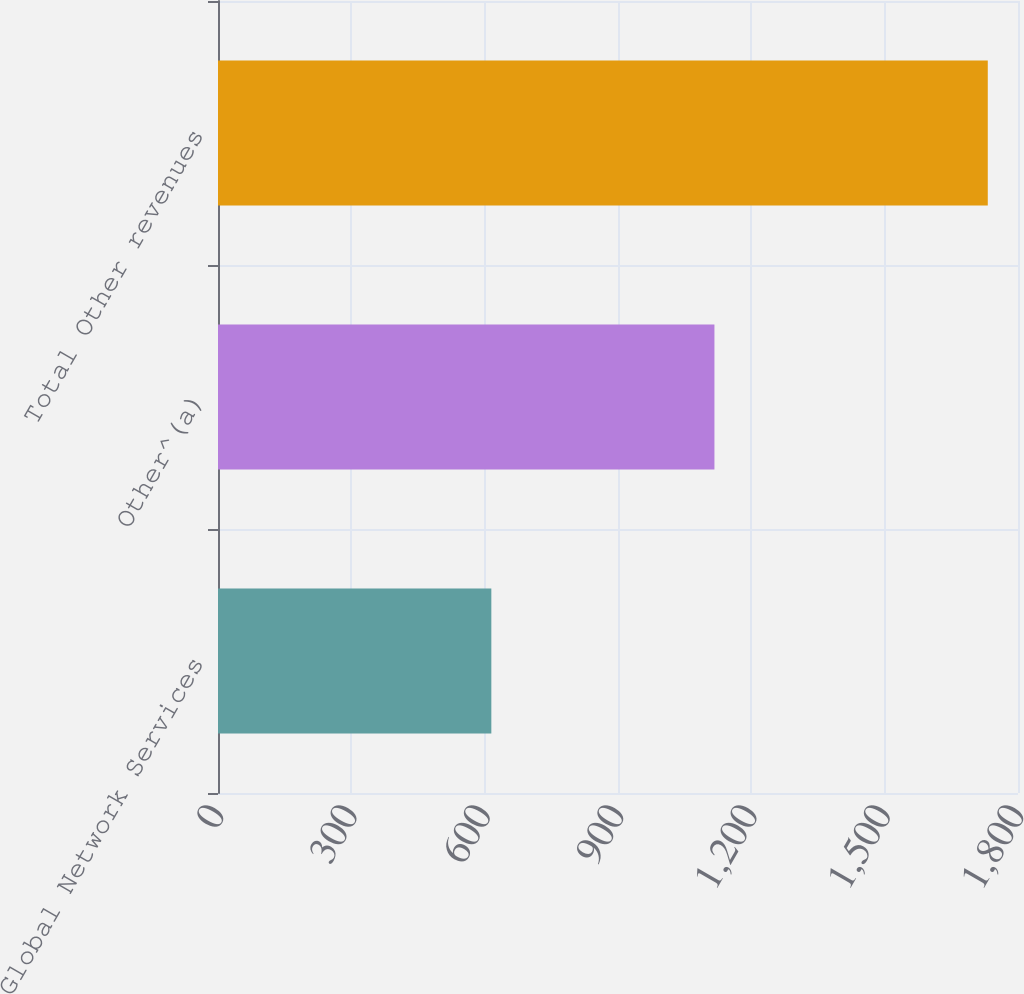<chart> <loc_0><loc_0><loc_500><loc_500><bar_chart><fcel>Global Network Services<fcel>Other^(a)<fcel>Total Other revenues<nl><fcel>615<fcel>1117<fcel>1732<nl></chart> 